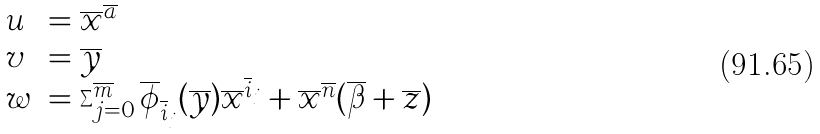<formula> <loc_0><loc_0><loc_500><loc_500>\begin{array} { l l } u & = \overline { x } ^ { \overline { a } } \\ v & = \overline { y } \\ w & = \sum _ { j = 0 } ^ { \overline { m } } \overline { \phi } _ { \overline { i } _ { j } } ( \overline { y } ) \overline { x } ^ { \overline { i } _ { j } } + \overline { x } ^ { \overline { n } } ( \overline { \beta } + \overline { z } ) \end{array}</formula> 